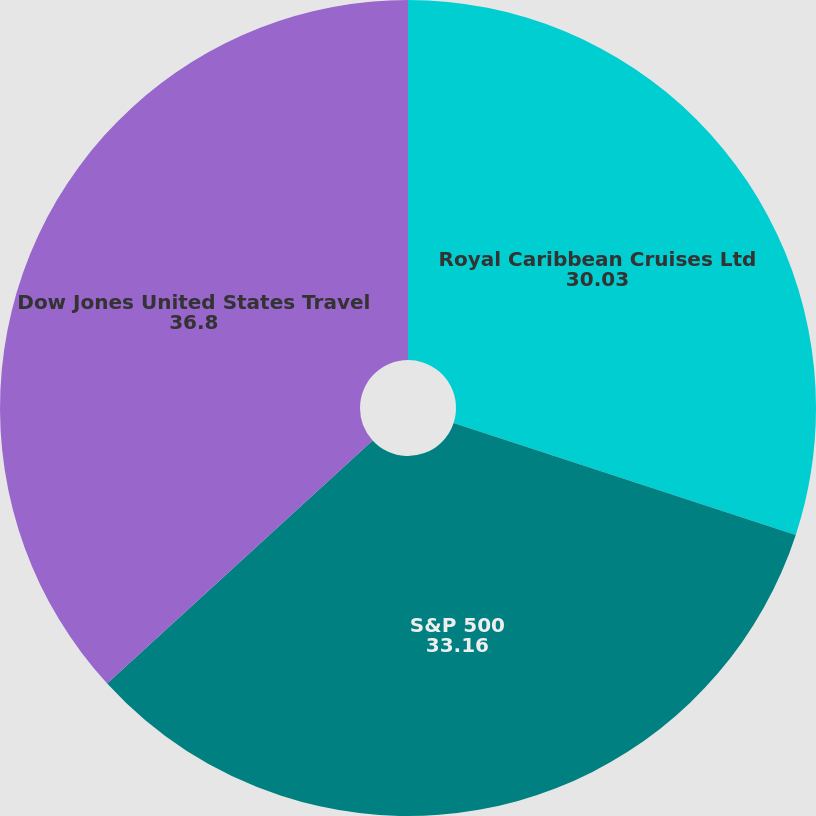<chart> <loc_0><loc_0><loc_500><loc_500><pie_chart><fcel>Royal Caribbean Cruises Ltd<fcel>S&P 500<fcel>Dow Jones United States Travel<nl><fcel>30.03%<fcel>33.16%<fcel>36.8%<nl></chart> 